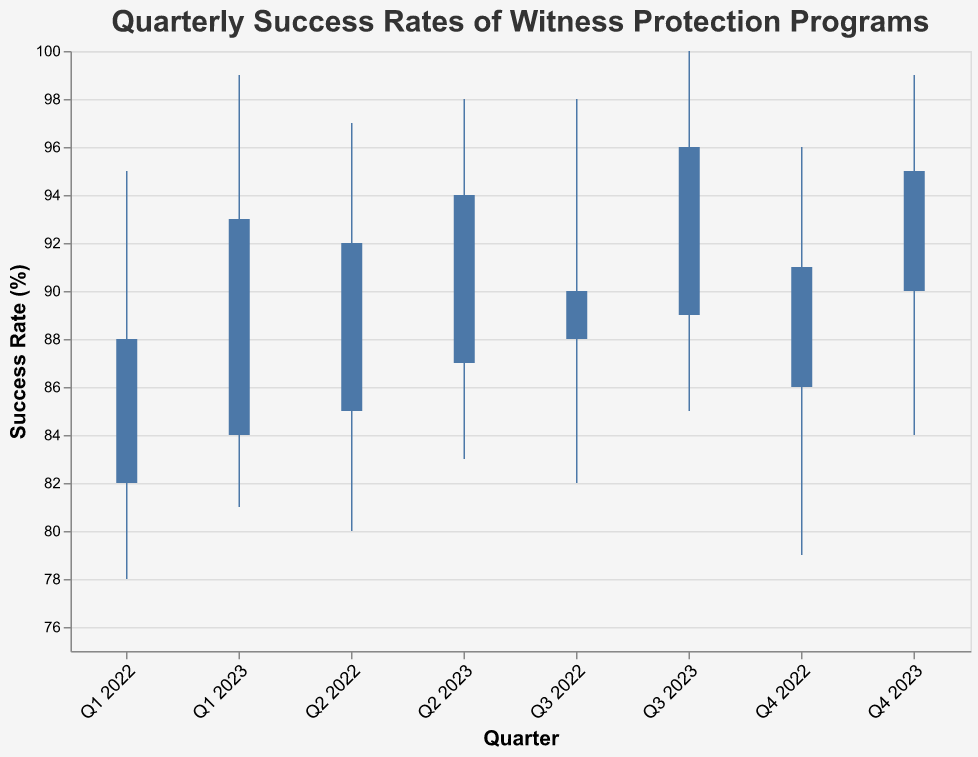what's the title of the OHLC chart? The title is located at the top of the chart and it reads "Quarterly Success Rates of Witness Protection Programs"
Answer: Quarterly Success Rates of Witness Protection Programs how many quarters are shown in the figure? The x-axis lists each quarter's label from Q1 2022 to Q4 2023, totaling 8 quarters
Answer: 8 what was the peak success rate in Q3 2023? Refer to the "Peak" value for Q3 2023, which is represented as a top endpoint of the vertical line for Q3 2023
Answer: 100 which quarter had the lowest final success rate? Compare all quarters' final success rates, indicated by the ends of the bar marks. Q1 2022 had the lowest final success rate of 88%
Answer: Q1 2022 how did the final success rate change between Q2 2023 and Q3 2023? The final rates for Q2 2023 and Q3 2023 are 94% and 96% respectively. The final rate increased by 2% from Q2 2023 to Q3 2023
Answer: increased by 2% what is the average initial success rate across all quarters? Sum initial rates (82 + 85 + 88 + 86 + 84 + 87 + 89 + 90) = 691. Average is 691/8 = 86.375
Answer: 86.375 which quarter showed the greatest range in success rates? Determine the range (Peak - Lowest) for each quarter and compare. Q3 2023 has the largest range (100 - 85 = 15)
Answer: Q3 2023 which quarter showed no improvement when comparing the initial and final success rates? Compare the initial and final rates. Q3 2022 saw no improvement as it went from 88% to 90%, which is not a perfect match, Q3 2022 still improved, so none
Answer: None how did the lowest success rate change from Q1 2022 to Q1 2023? The lowest success rates are 78% for Q1 2022 and 81% for Q1 2023. The rate increased by 3%
Answer: increased by 3% what is the difference between the highest and lowest peaks observed in the data? The highest peak is 100 (Q3 2023) and the lowest peak is 95 (Q1 2022). The difference is 100 - 95 = 5
Answer: 5 